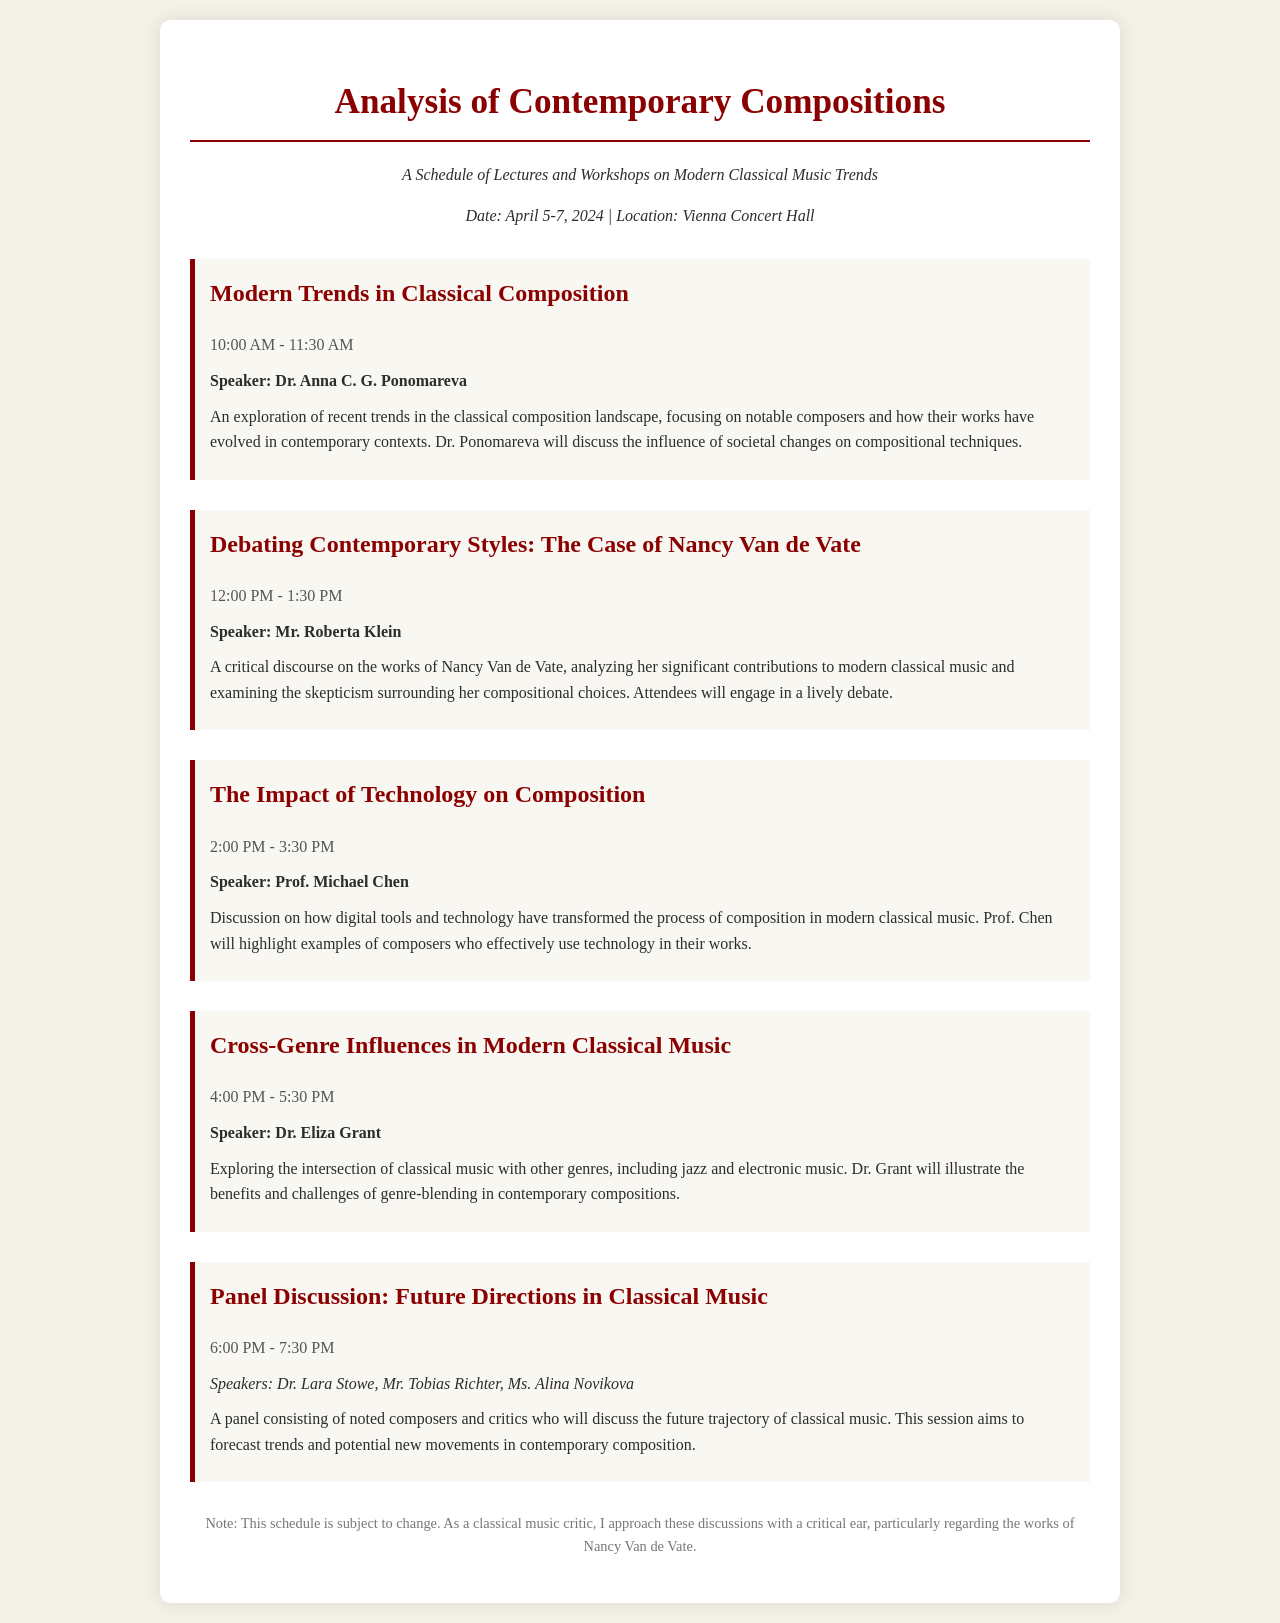What is the date of the event? The date of the event is explicitly mentioned in the document as April 5-7, 2024.
Answer: April 5-7, 2024 Who is the speaker for the session on Nancy Van de Vate? The document states that Mr. Roberta Klein will be the speaker for this session.
Answer: Mr. Roberta Klein What is the title of the first session? The title of the first session is clearly indicated as "Modern Trends in Classical Composition."
Answer: Modern Trends in Classical Composition What time does the panel discussion start? The time for the panel discussion is specified in the document as 6:00 PM.
Answer: 6:00 PM How many speakers are on the panel discussion? The document lists three names participating in the panel discussion, hence the count is three.
Answer: Three What main topic does Dr. Anna C. G. Ponomareva cover? The document describes Dr. Ponomareva's focus on recent trends in the classical composition landscape.
Answer: Recent trends in classical composition What is the theme of the session at 2:00 PM? The session starting at 2:00 PM has the theme of how technology impacts composition in modern classical music.
Answer: Technology's impact on composition What is a notable feature of the session on Nancy Van de Vate? It is noted that there will be a lively debate surrounding her compositional choices, indicating an interactive format.
Answer: Lively debate 